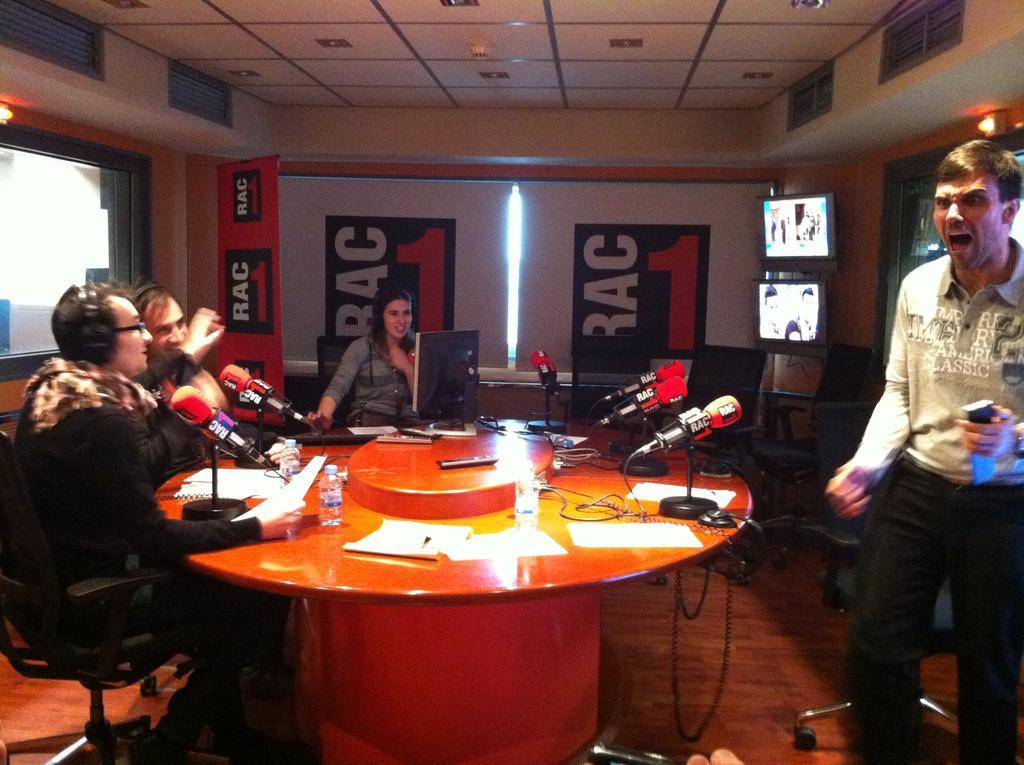Describe this image in one or two sentences. In this picture there are three people sitting on a chair. There is a mic, computer, bottle , papers, remote on the table. There is a man holding an object and standing. There is a light and a television. 